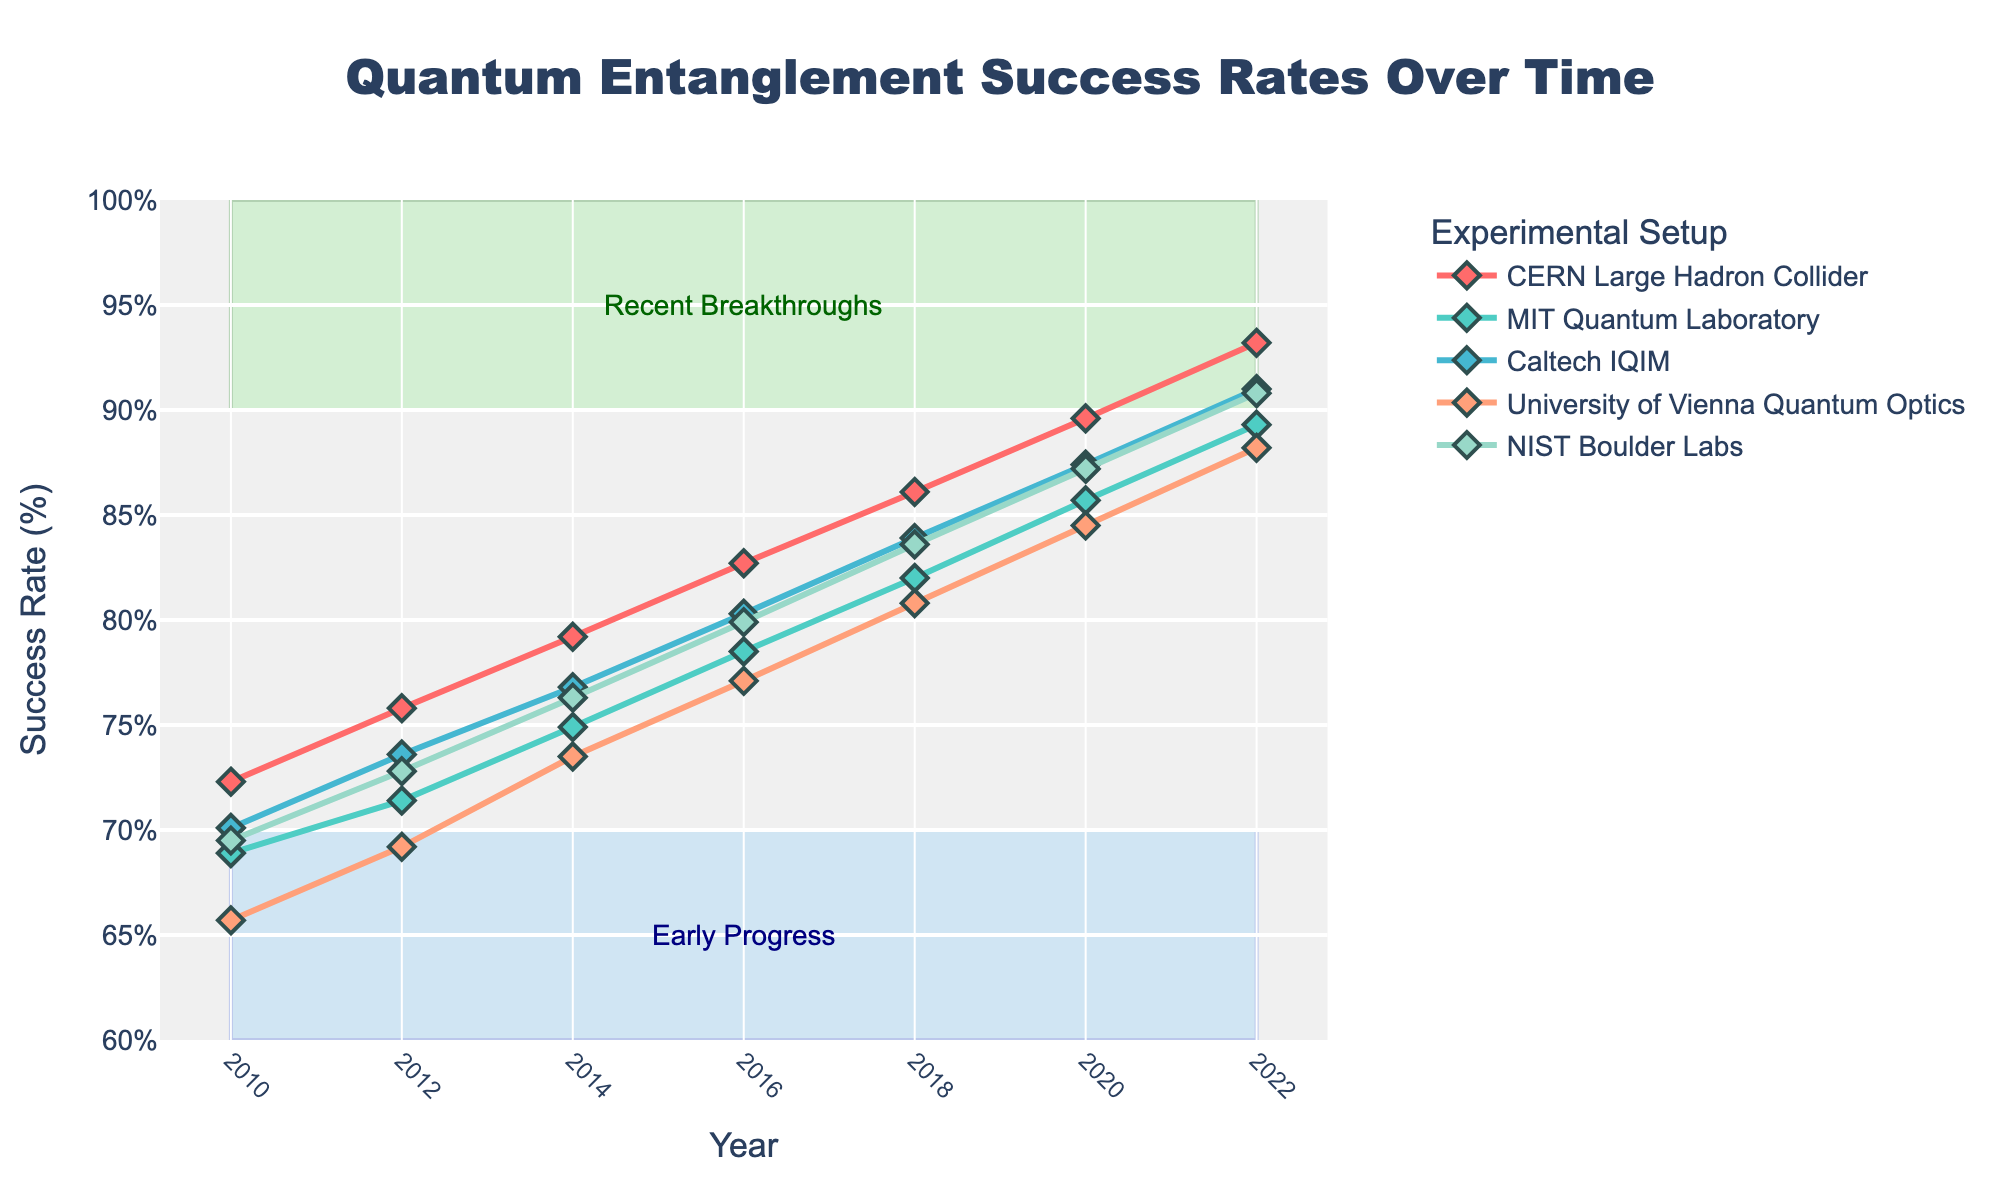What is the overall trend observed in the success rates of quantum entanglement experiments from 2010 to 2022? To answer this, look at the lines on the chart for each experimental setup. Each line shows a consistent increase in success rates over time from 2010 to 2022.
Answer: Increasing Which experimental setup showed the highest success rate in the year 2020? Find the points corresponding to the year 2020 and look for the highest value. The CERN Large Hadron Collider has the highest success rate in 2020.
Answer: CERN Large Hadron Collider By how many percentage points did the success rate of the MIT Quantum Laboratory increase from 2010 to 2022? Subtract the success rate of MIT Quantum Laboratory in 2010 from its success rate in 2022. The increase is 89.3 - 68.9.
Answer: 20.4 Which two experimental setups had the closest success rates in 2018, and what were those rates? Compare the success rates of all setups in 2018. The closest rates are for the University of Vienna Quantum Optics and NIST Boulder Labs, both at around 80.8 and 83.6, respectively.
Answer: University of Vienna Quantum Optics (80.8), NIST Boulder Labs (83.6) Calculate the average success rate for Caltech IQIM over the given years. Add the success rates for Caltech IQIM over the years 2010 to 2022 and divide by the number of years. (70.1 + 73.6 + 76.8 + 80.3 + 83.9 + 87.4 + 91.0) / 7.
Answer: 80.44 Between which two consecutive years did the NIST Boulder Labs see the largest increase in success rate? Calculate the difference between consecutive points for NIST Boulder Labs. The largest increase is between 2010 (69.5) and 2012 (72.8), which is 3.3 percentage points.
Answer: 2010 to 2012 Describe the shape and placement of the areas highlighted by rectangles in the chart. The chart has two rectangular areas highlighted: one from 2010 to 2022, success rates between 60% and 70%, shaded in light blue, and another from 2010 to 2022 between 90% and 100%, shaded in light green.
Answer: Light blue at the bottom, light green at the top Which year marks the highest overall success rates for all experimental setups combined? Check the data points across all years and find the year with the highest success rates for all experimental setups. The year 2022 has the highest rates for all setups.
Answer: 2022 How does the success rate trend for the University of Vienna Quantum Optics compare to the overall trend? The success rate for University of Vienna Quantum Optics also shows an increasing trend but starts lower and remains slightly lower than others over the years.
Answer: Increasing, slightly lower 